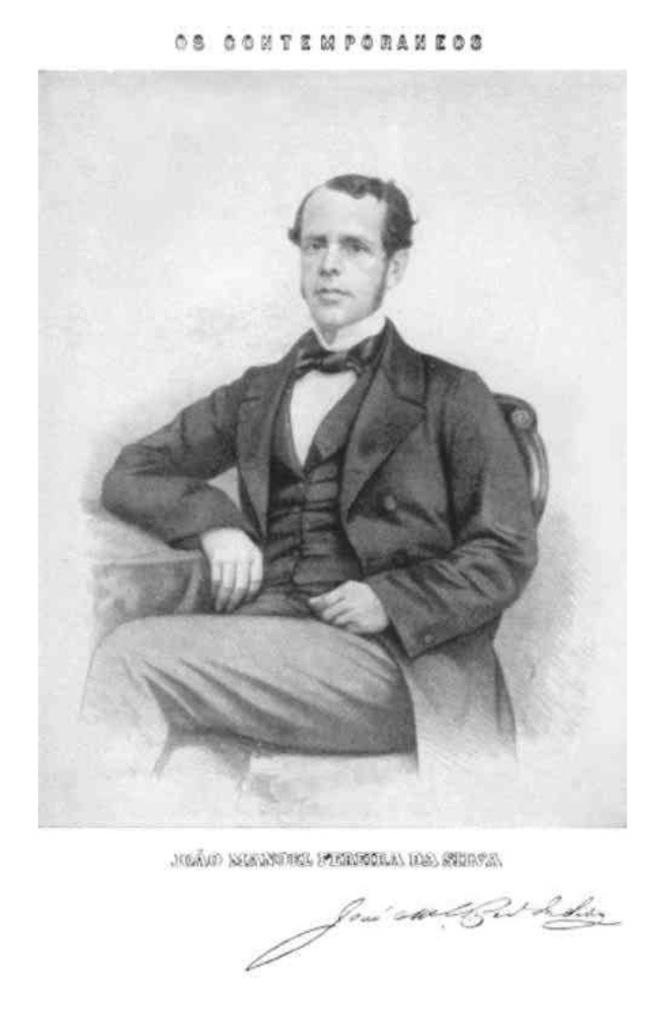What is the color scheme of the image? The image is black and white. What is the main subject in the image? There is a man sitting on a chair in the center of the image. Where can text be found in the image? There is text at the top and bottom of the image. Can you see a basketball being played on the island in the image? There is no basketball or island present in the image. How many clovers are growing near the man in the image? There are no clovers visible in the image; it is a black and white image with a man sitting on a chair and text at the top and bottom. 